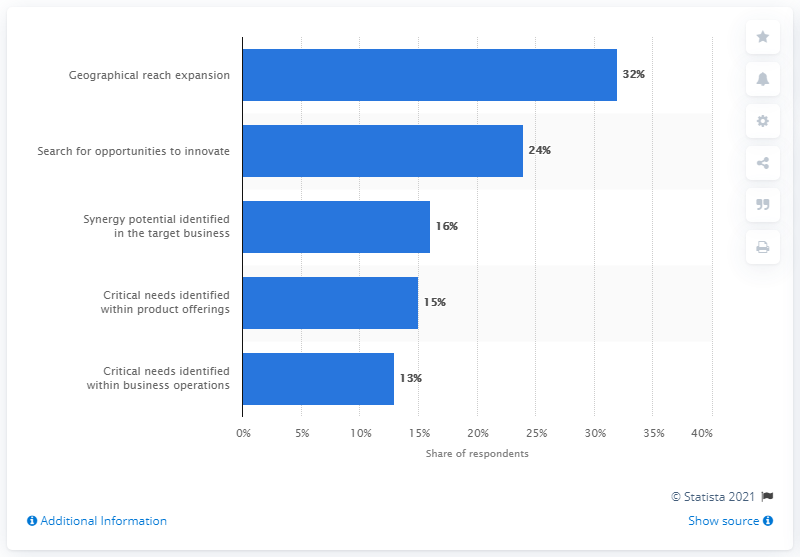Mention a couple of crucial points in this snapshot. According to the survey results, approximately 32% of respondents reported that geographic reach was the primary motivation behind their last acquisition. 